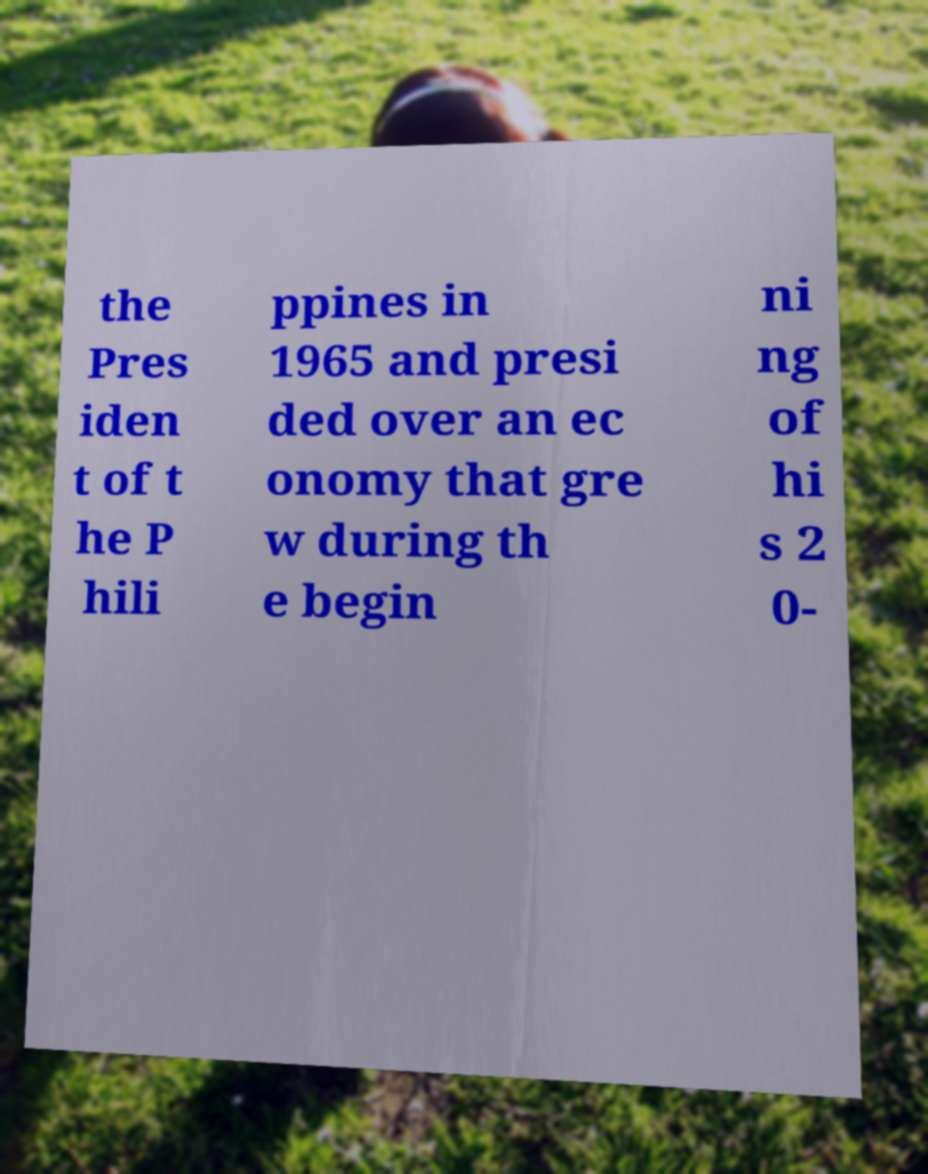There's text embedded in this image that I need extracted. Can you transcribe it verbatim? the Pres iden t of t he P hili ppines in 1965 and presi ded over an ec onomy that gre w during th e begin ni ng of hi s 2 0- 